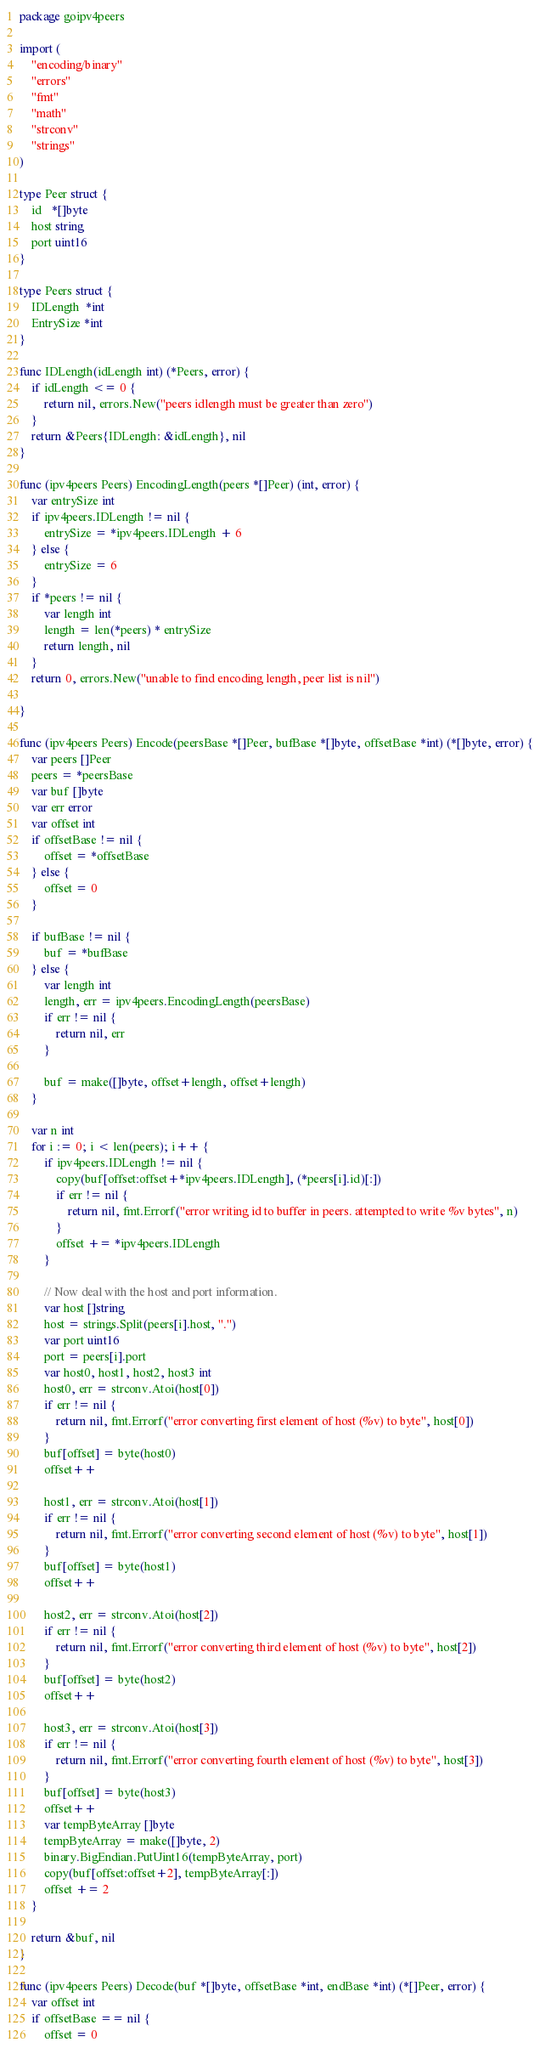Convert code to text. <code><loc_0><loc_0><loc_500><loc_500><_Go_>package goipv4peers

import (
	"encoding/binary"
	"errors"
	"fmt"
	"math"
	"strconv"
	"strings"
)

type Peer struct {
	id   *[]byte
	host string
	port uint16
}

type Peers struct {
	IDLength  *int
	EntrySize *int
}

func IDLength(idLength int) (*Peers, error) {
	if idLength <= 0 {
		return nil, errors.New("peers idlength must be greater than zero")
	}
	return &Peers{IDLength: &idLength}, nil
}

func (ipv4peers Peers) EncodingLength(peers *[]Peer) (int, error) {
	var entrySize int
	if ipv4peers.IDLength != nil {
		entrySize = *ipv4peers.IDLength + 6
	} else {
		entrySize = 6
	}
	if *peers != nil {
		var length int
		length = len(*peers) * entrySize
		return length, nil
	}
	return 0, errors.New("unable to find encoding length, peer list is nil")

}

func (ipv4peers Peers) Encode(peersBase *[]Peer, bufBase *[]byte, offsetBase *int) (*[]byte, error) {
	var peers []Peer
	peers = *peersBase
	var buf []byte
	var err error
	var offset int
	if offsetBase != nil {
		offset = *offsetBase
	} else {
		offset = 0
	}

	if bufBase != nil {
		buf = *bufBase
	} else {
		var length int
		length, err = ipv4peers.EncodingLength(peersBase)
		if err != nil {
			return nil, err
		}

		buf = make([]byte, offset+length, offset+length)
	}

	var n int
	for i := 0; i < len(peers); i++ {
		if ipv4peers.IDLength != nil {
			copy(buf[offset:offset+*ipv4peers.IDLength], (*peers[i].id)[:])
			if err != nil {
				return nil, fmt.Errorf("error writing id to buffer in peers. attempted to write %v bytes", n)
			}
			offset += *ipv4peers.IDLength
		}

		// Now deal with the host and port information.
		var host []string
		host = strings.Split(peers[i].host, ".")
		var port uint16
		port = peers[i].port
		var host0, host1, host2, host3 int
		host0, err = strconv.Atoi(host[0])
		if err != nil {
			return nil, fmt.Errorf("error converting first element of host (%v) to byte", host[0])
		}
		buf[offset] = byte(host0)
		offset++

		host1, err = strconv.Atoi(host[1])
		if err != nil {
			return nil, fmt.Errorf("error converting second element of host (%v) to byte", host[1])
		}
		buf[offset] = byte(host1)
		offset++

		host2, err = strconv.Atoi(host[2])
		if err != nil {
			return nil, fmt.Errorf("error converting third element of host (%v) to byte", host[2])
		}
		buf[offset] = byte(host2)
		offset++

		host3, err = strconv.Atoi(host[3])
		if err != nil {
			return nil, fmt.Errorf("error converting fourth element of host (%v) to byte", host[3])
		}
		buf[offset] = byte(host3)
		offset++
		var tempByteArray []byte
		tempByteArray = make([]byte, 2)
		binary.BigEndian.PutUint16(tempByteArray, port)
		copy(buf[offset:offset+2], tempByteArray[:])
		offset += 2
	}

	return &buf, nil
}

func (ipv4peers Peers) Decode(buf *[]byte, offsetBase *int, endBase *int) (*[]Peer, error) {
	var offset int
	if offsetBase == nil {
		offset = 0</code> 